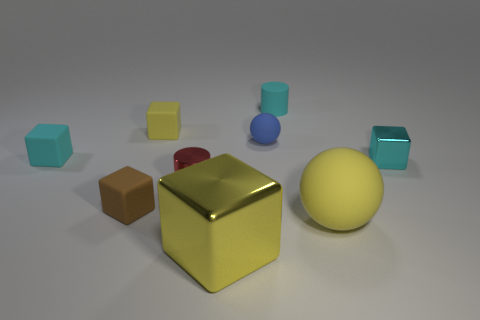The cylinder in front of the yellow cube behind the yellow matte thing that is on the right side of the tiny yellow rubber thing is made of what material?
Keep it short and to the point. Metal. What color is the large object that is on the right side of the yellow metallic cube that is on the right side of the small red metallic thing?
Your answer should be very brief. Yellow. What color is the matte cylinder that is the same size as the cyan matte cube?
Provide a short and direct response. Cyan. What number of large objects are balls or cyan shiny cubes?
Ensure brevity in your answer.  1. Are there more big shiny blocks that are on the right side of the large rubber sphere than yellow shiny cubes that are left of the small brown object?
Your answer should be very brief. No. There is a shiny thing that is the same color as the tiny matte cylinder; what is its size?
Provide a succinct answer. Small. What number of other objects are there of the same size as the brown thing?
Your answer should be very brief. 6. Do the large sphere in front of the cyan rubber cylinder and the big yellow cube have the same material?
Provide a succinct answer. No. What number of other objects are there of the same color as the matte cylinder?
Provide a short and direct response. 2. How many other things are there of the same shape as the small red object?
Keep it short and to the point. 1. 